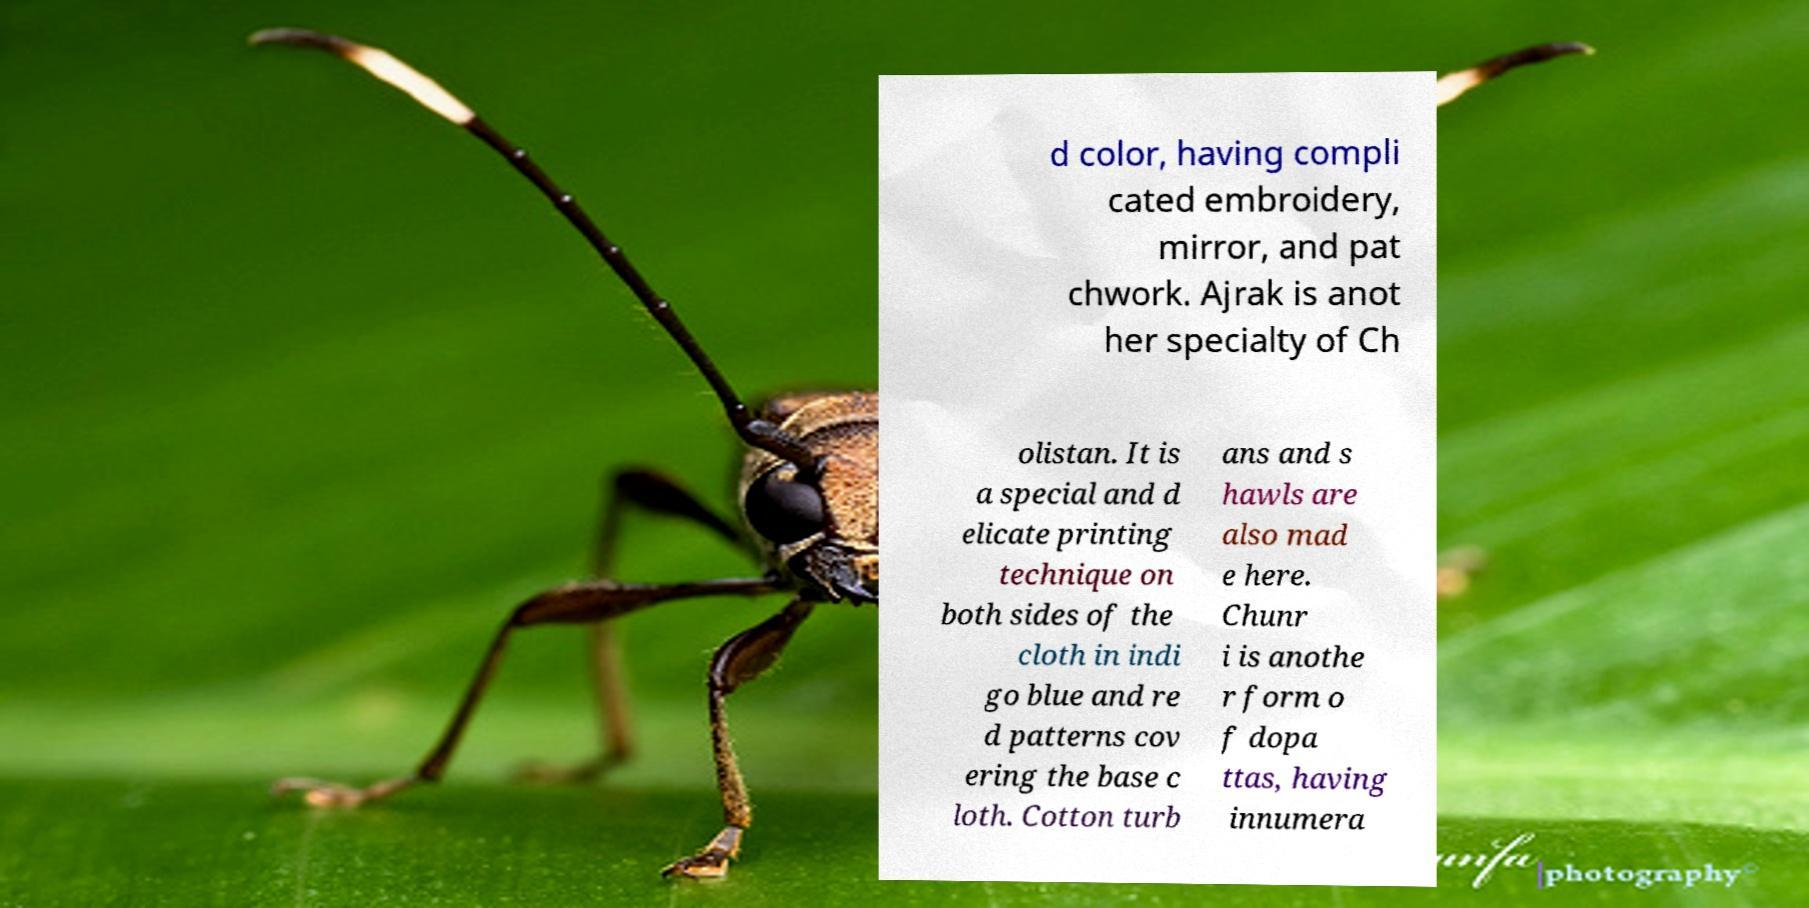Can you read and provide the text displayed in the image?This photo seems to have some interesting text. Can you extract and type it out for me? d color, having compli cated embroidery, mirror, and pat chwork. Ajrak is anot her specialty of Ch olistan. It is a special and d elicate printing technique on both sides of the cloth in indi go blue and re d patterns cov ering the base c loth. Cotton turb ans and s hawls are also mad e here. Chunr i is anothe r form o f dopa ttas, having innumera 